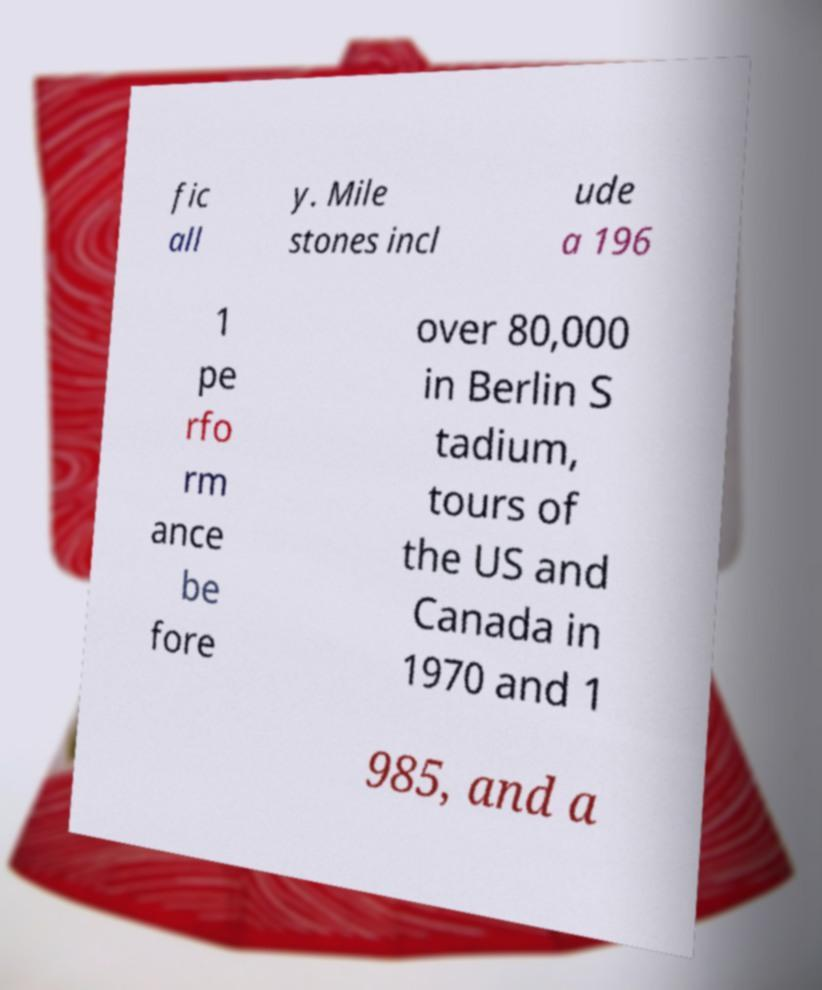Can you read and provide the text displayed in the image?This photo seems to have some interesting text. Can you extract and type it out for me? fic all y. Mile stones incl ude a 196 1 pe rfo rm ance be fore over 80,000 in Berlin S tadium, tours of the US and Canada in 1970 and 1 985, and a 